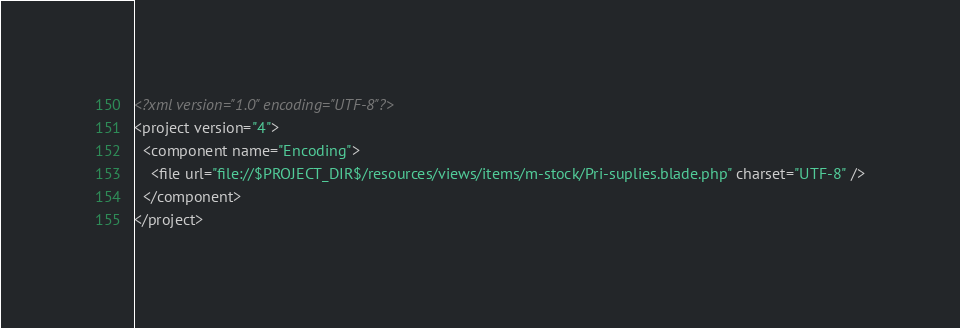Convert code to text. <code><loc_0><loc_0><loc_500><loc_500><_XML_><?xml version="1.0" encoding="UTF-8"?>
<project version="4">
  <component name="Encoding">
    <file url="file://$PROJECT_DIR$/resources/views/items/m-stock/Pri-suplies.blade.php" charset="UTF-8" />
  </component>
</project></code> 